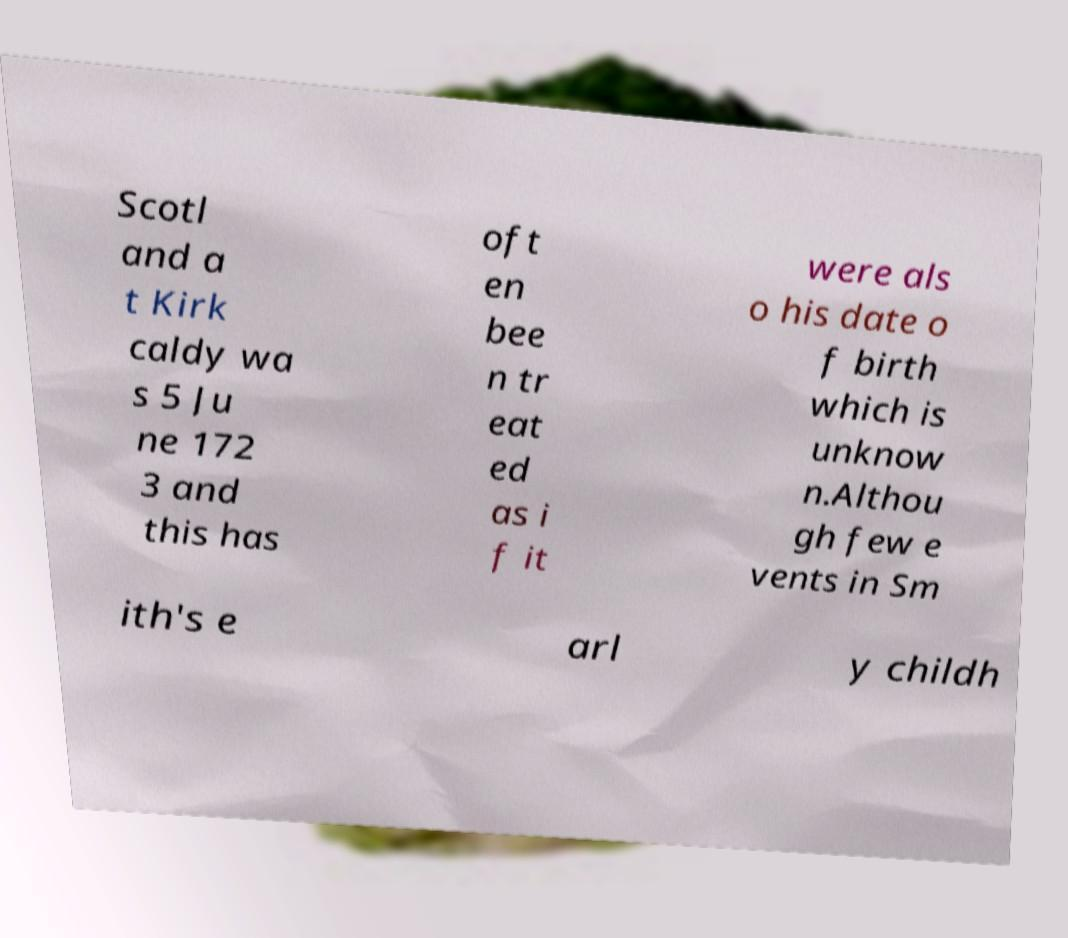I need the written content from this picture converted into text. Can you do that? Scotl and a t Kirk caldy wa s 5 Ju ne 172 3 and this has oft en bee n tr eat ed as i f it were als o his date o f birth which is unknow n.Althou gh few e vents in Sm ith's e arl y childh 